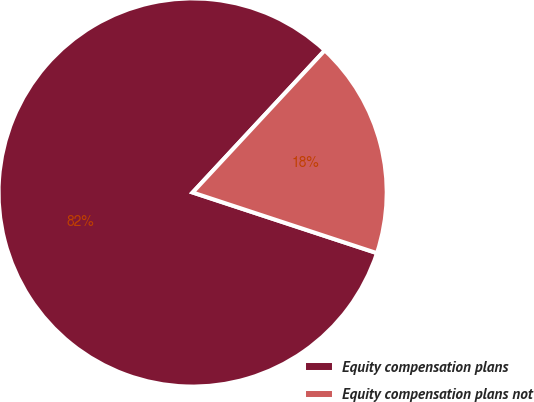Convert chart to OTSL. <chart><loc_0><loc_0><loc_500><loc_500><pie_chart><fcel>Equity compensation plans<fcel>Equity compensation plans not<nl><fcel>81.86%<fcel>18.14%<nl></chart> 